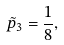Convert formula to latex. <formula><loc_0><loc_0><loc_500><loc_500>\tilde { p } _ { 3 } = \frac { 1 } { 8 } ,</formula> 